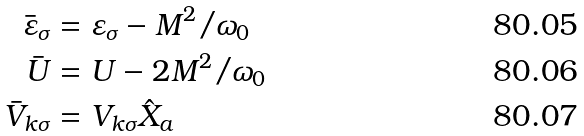<formula> <loc_0><loc_0><loc_500><loc_500>\bar { \varepsilon } _ { \sigma } & = \varepsilon _ { \sigma } - M ^ { 2 } / \omega _ { 0 } \\ \bar { U } & = U - 2 M ^ { 2 } / \omega _ { 0 } \\ \bar { V } _ { k \sigma } & = V _ { k \sigma } \hat { X } _ { a }</formula> 